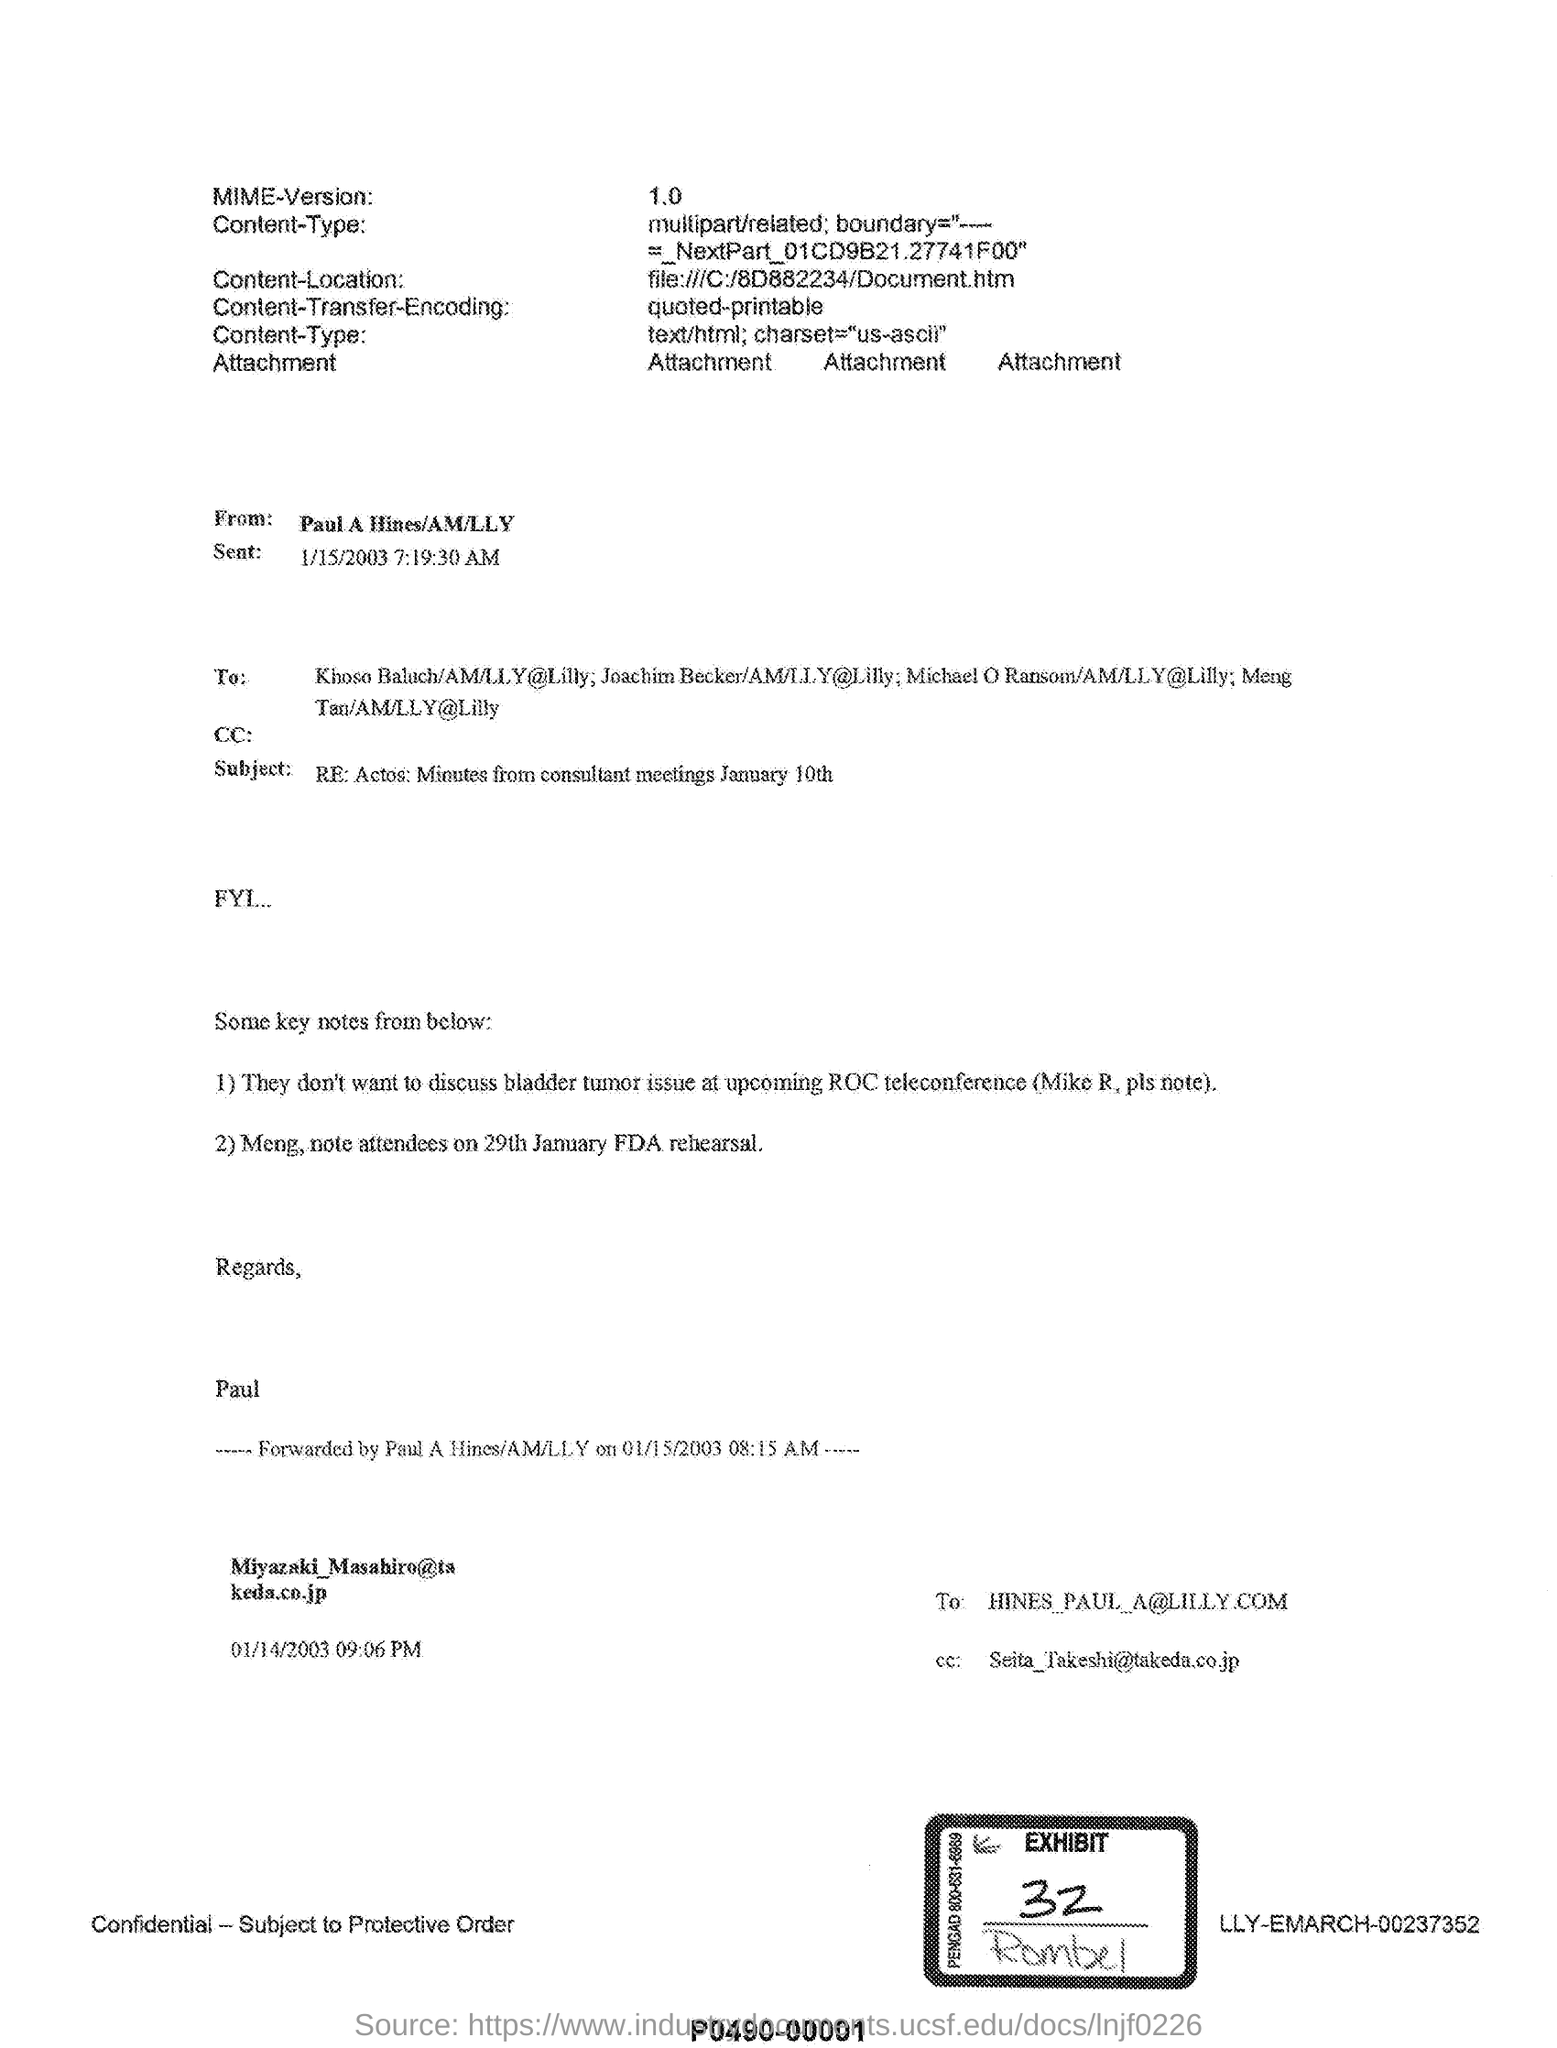Give some essential details in this illustration. The subject of the email from Paul A Hines is "Re: Actos: Minutes from consultant meetings January 10th. Exhibit No. 32 is mentioned in the document. 